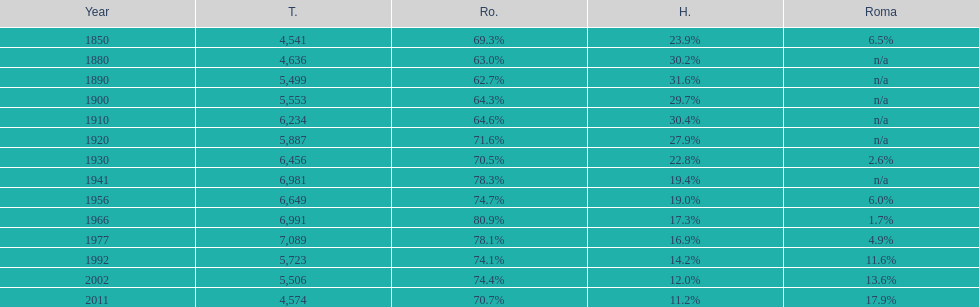In how many occurrences did the total population surpass or equal 6,000? 6. 